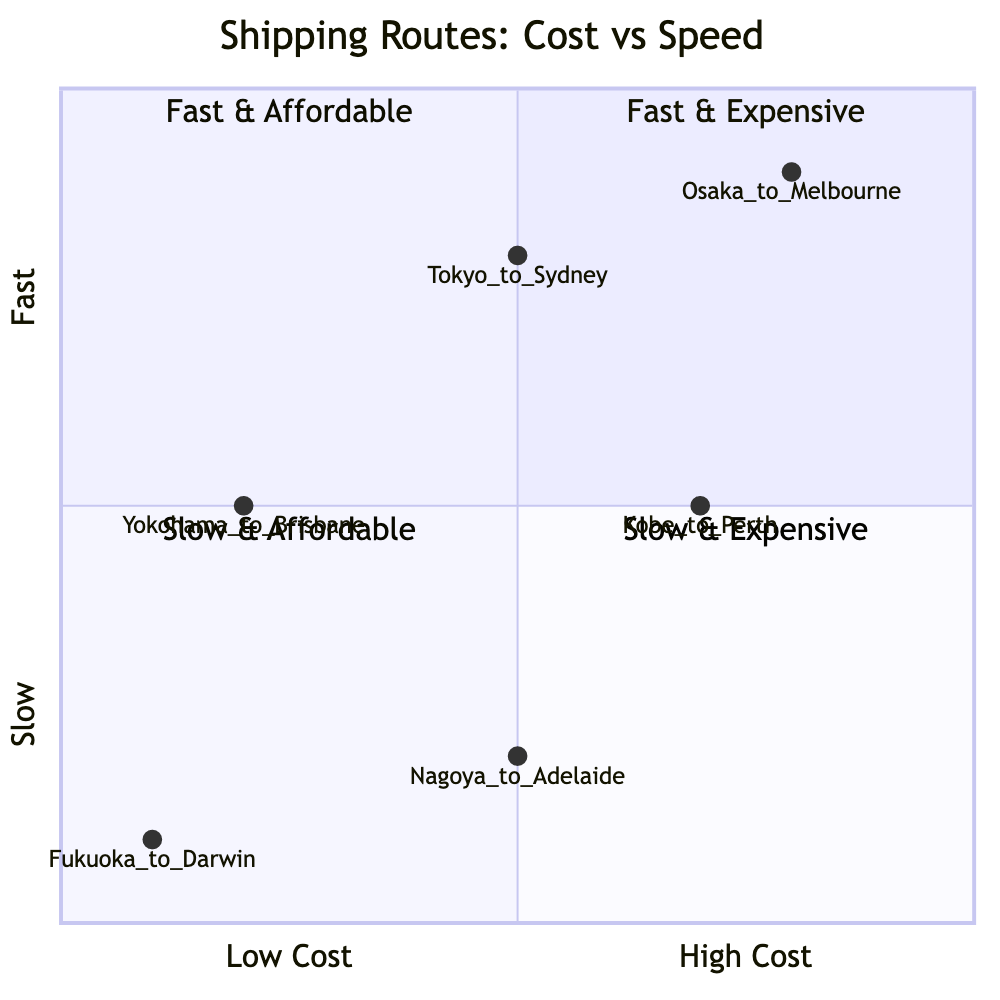What is the fastest shipping route? The fastest route is identified by the highest point on the y-axis in the quadrant chart. The "Osaka to Melbourne" and "Tokyo to Sydney" routes are both categorized as "Fast," but since they are close to the upper section of the quadrant chart, we see they represent different costs, with "Osaka to Melbourne" being the expensive option.
Answer: Osaka to Melbourne Which shipping route is the most cost-effective? The cost-effective route can be found by identifying the node with the lowest position on the x-axis, which represents the "Low Cost" category. According to the data, "Fukuoka to Darwin" has been tagged under "Low" costs.
Answer: Fukuoka to Darwin How many shipping routes are classified as slow and affordable? To find the number of routes classified as "Slow & Affordable," we look for nodes in quadrant 3 within the chart. In this case, only the "Fukuoka to Darwin" and "Yokohama to Brisbane" shipping routes fit this classification when listed under the categories of speed and cost.
Answer: 2 What is the cost of the fastest and expensive shipping route? To determine the cost of the fastest and expensive route, we can look at the quadrants where the highest speed corresponds with the "High" cost. "Osaka to Melbourne," being both fast and expensive, fits this criteria.
Answer: High Which shipping route is both slow and expensive? The route that is categorized under both "Slow" and "High Cost" can be identified by checking the nodes in quadrant 4. In this scenario, the only shipping route listed in this quadrant is "Kobe to Perth."
Answer: Kobe to Perth What additional information is provided for "Yokohama to Brisbane"? To find the additional info for the route, we need to refer to the associated data point for "Yokohama to Brisbane." The data provided states that it is cost-effective for bulk shipments which gives insight into why it is preferred for those types of loads.
Answer: Cost-effective for bulk shipments How many routes are in the "Fast & Affordable" quadrant? By reviewing the quadrant chart, we can identify which routes are located in quadrant 2 labeled "Fast & Affordable." The "Tokyo to Sydney" route fits this profile, leading us to determine how many such routes are present.
Answer: 1 Which route has medium speed and high cost? This route can be identified by finding the intersection of "Medium Speed" on the y-axis and "High Cost" on the x-axis. According to the data provided, "Kobe to Perth" meets both of these criteria.
Answer: Kobe to Perth 